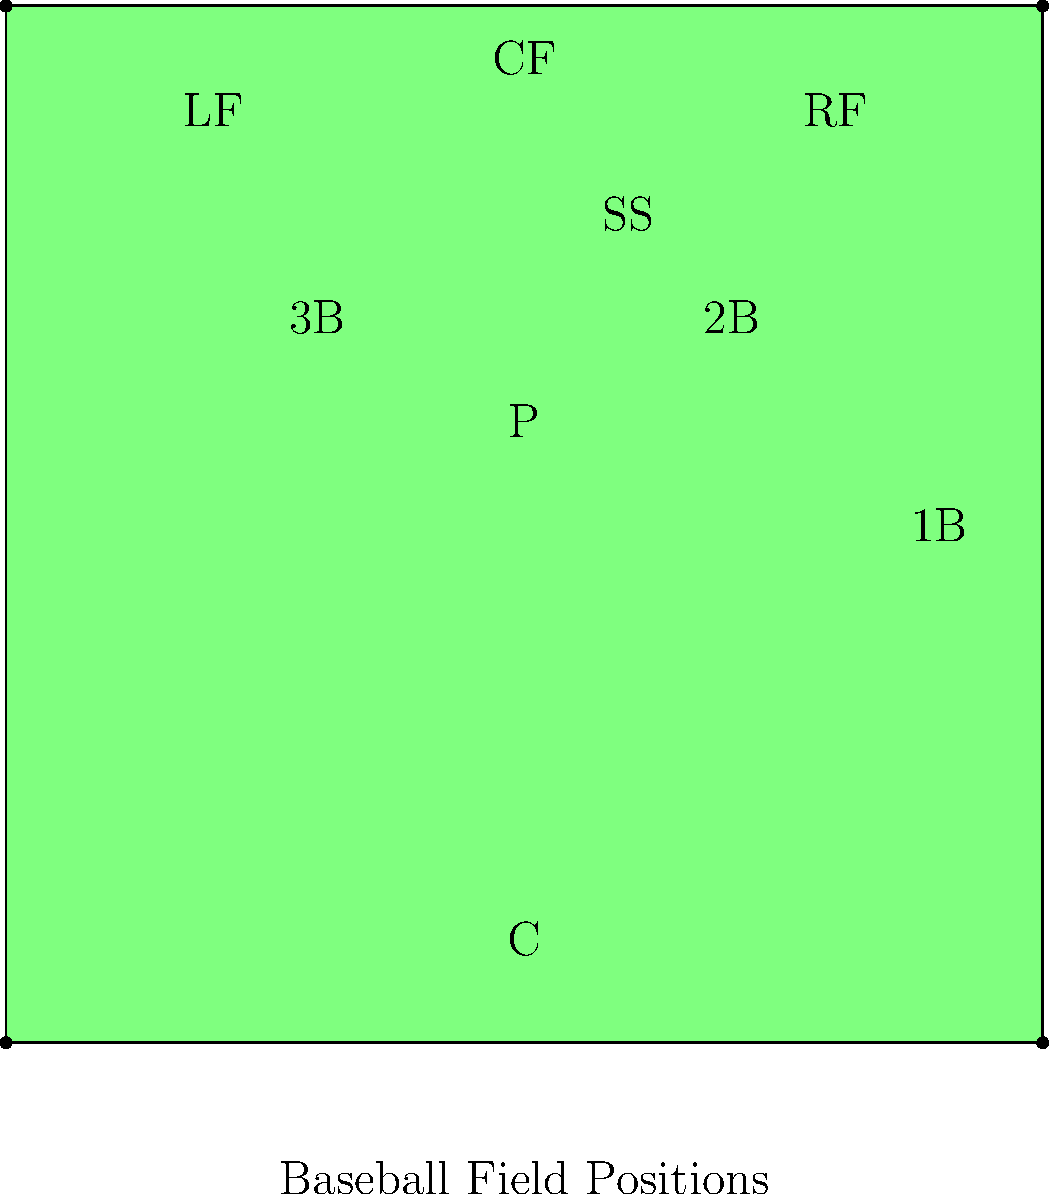In the baseball field diagram above, which position is located between second base and third base? To answer this question, let's follow these steps:

1. Identify the bases:
   - Home plate is at the bottom of the diamond.
   - First base (1B) is on the right.
   - Second base is at the top right corner.
   - Third base is at the top left corner.

2. Locate the position between second and third base:
   - Looking at the area between second and third base, we see a position labeled "SS".

3. Understand what "SS" stands for:
   - In baseball, "SS" is the abbreviation for "shortstop".

4. Confirm the shortstop's typical position:
   - The shortstop typically plays between second and third base, which matches the diagram.

Therefore, the position located between second base and third base is the shortstop (SS).
Answer: Shortstop (SS) 